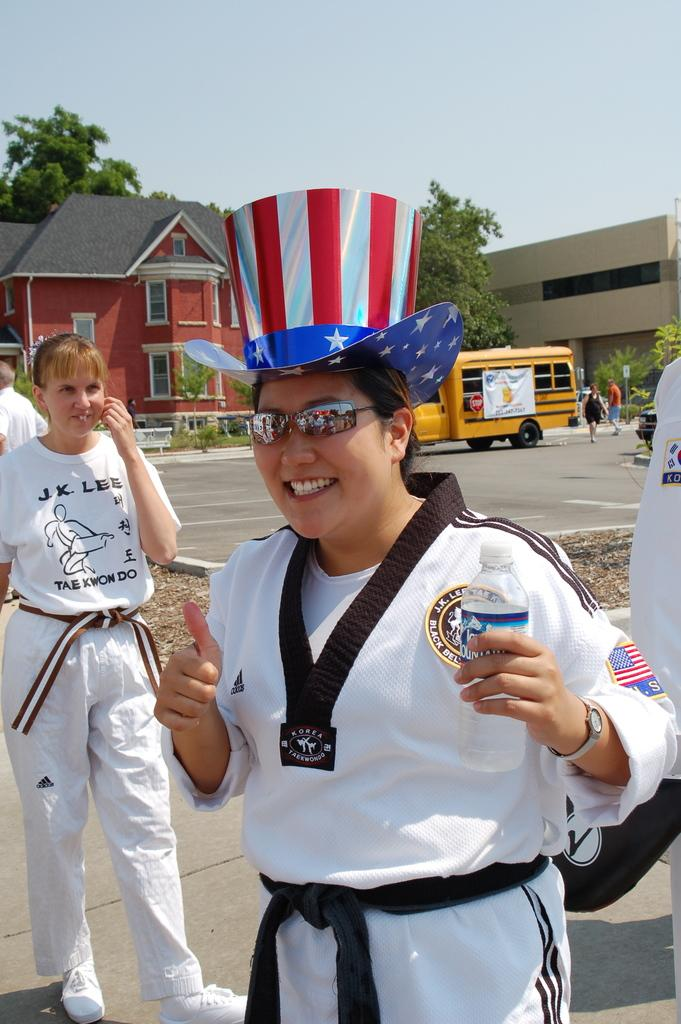<image>
Provide a brief description of the given image. A woman with a black belt in tae kwon do is wearing an Uncle Sam hat. 